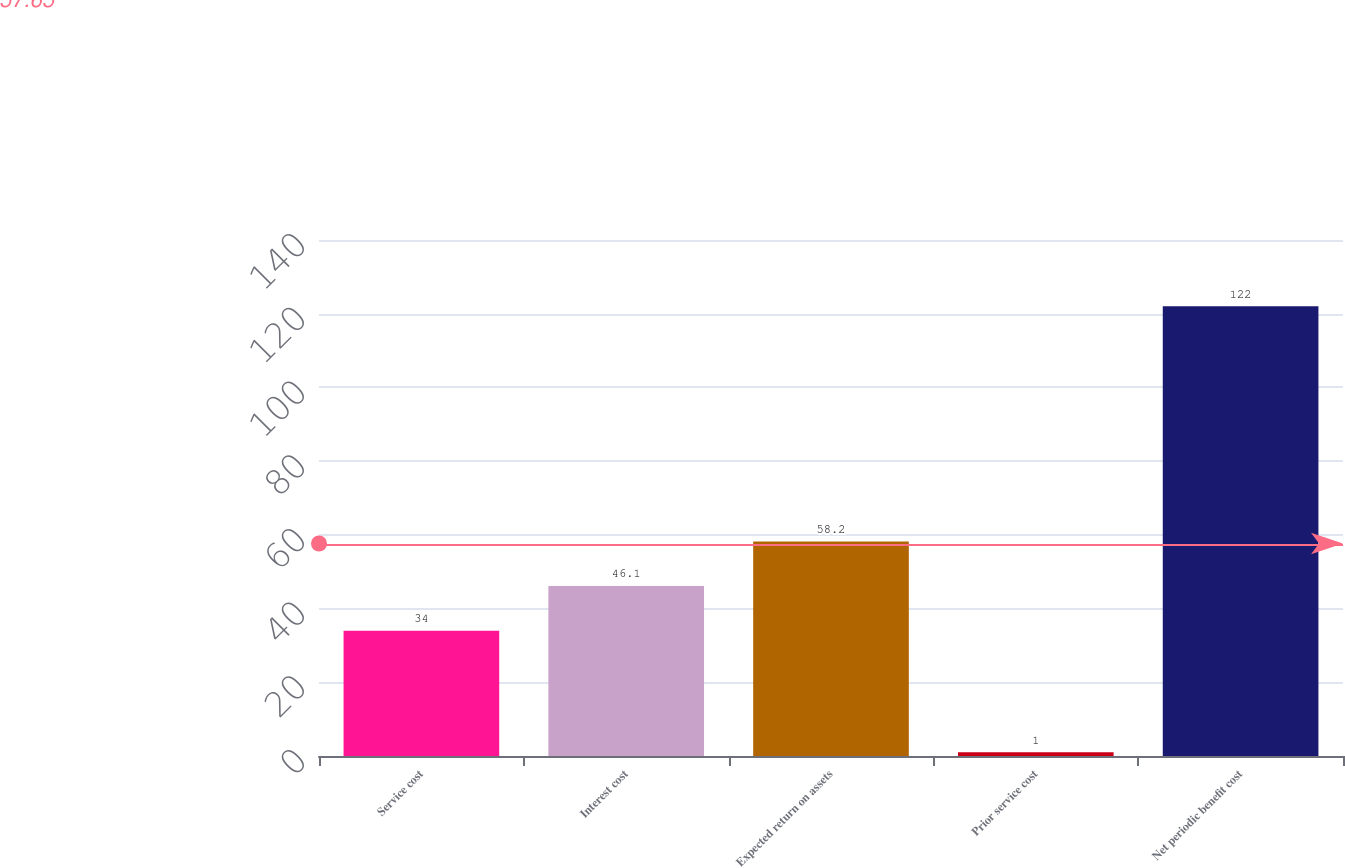Convert chart. <chart><loc_0><loc_0><loc_500><loc_500><bar_chart><fcel>Service cost<fcel>Interest cost<fcel>Expected return on assets<fcel>Prior service cost<fcel>Net periodic benefit cost<nl><fcel>34<fcel>46.1<fcel>58.2<fcel>1<fcel>122<nl></chart> 